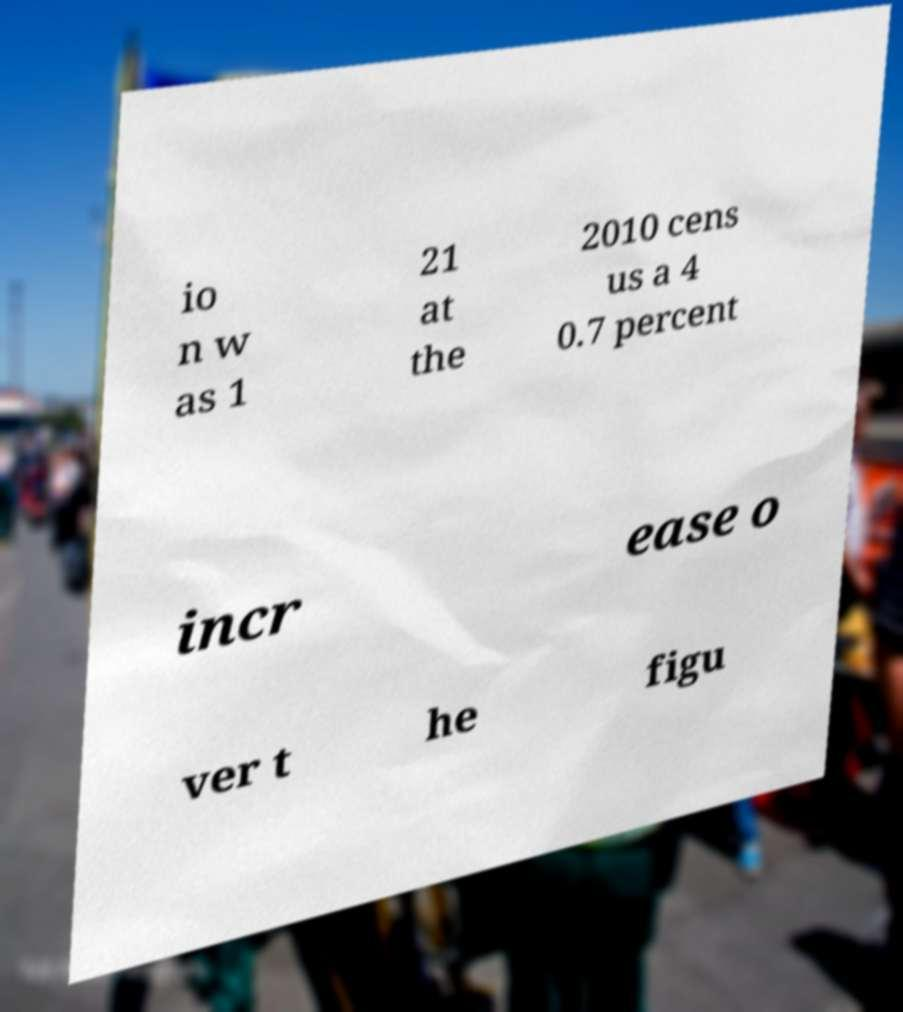Can you read and provide the text displayed in the image?This photo seems to have some interesting text. Can you extract and type it out for me? io n w as 1 21 at the 2010 cens us a 4 0.7 percent incr ease o ver t he figu 